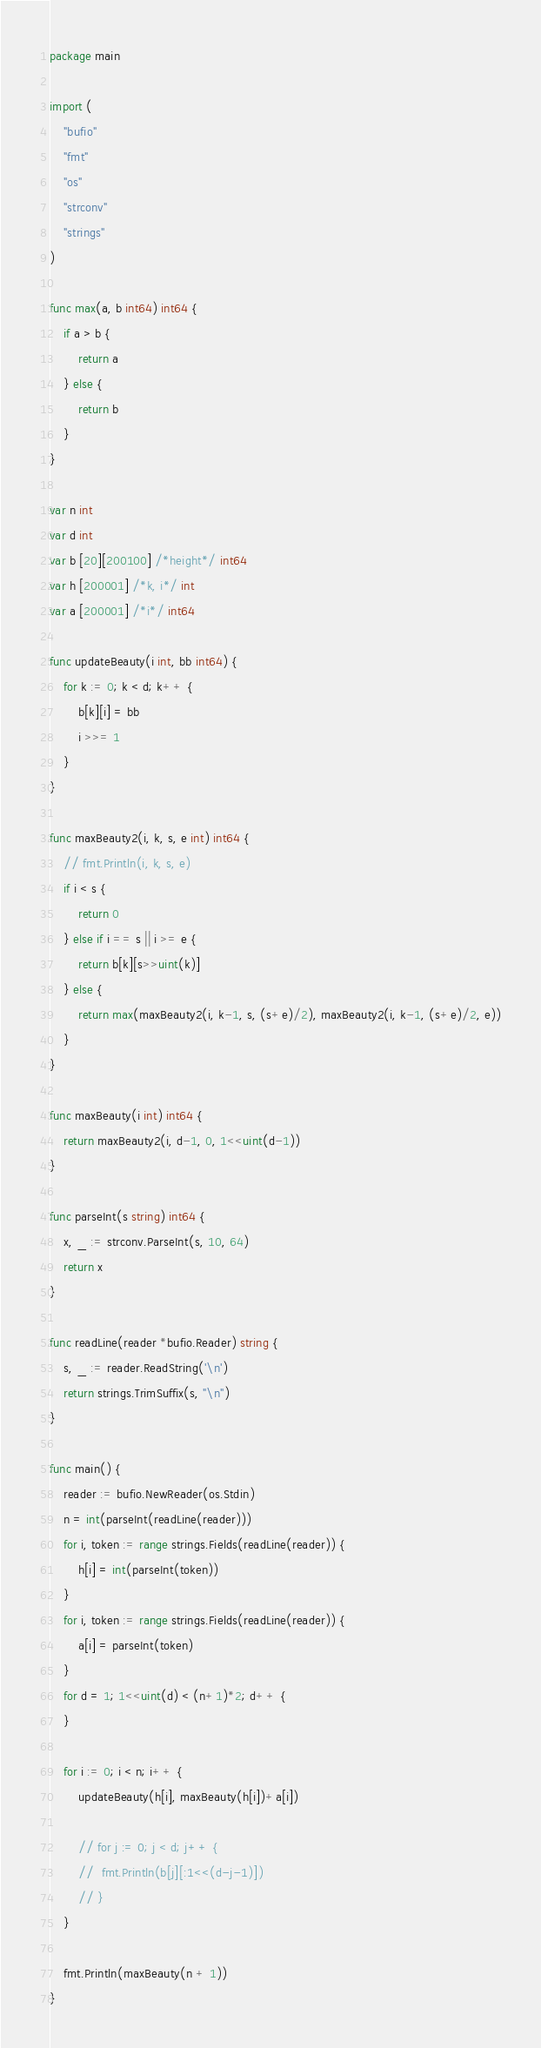<code> <loc_0><loc_0><loc_500><loc_500><_Go_>package main

import (
	"bufio"
	"fmt"
	"os"
	"strconv"
	"strings"
)

func max(a, b int64) int64 {
	if a > b {
		return a
	} else {
		return b
	}
}

var n int
var d int
var b [20][200100] /*height*/ int64
var h [200001] /*k, i*/ int
var a [200001] /*i*/ int64

func updateBeauty(i int, bb int64) {
	for k := 0; k < d; k++ {
		b[k][i] = bb
		i >>= 1
	}
}

func maxBeauty2(i, k, s, e int) int64 {
	// fmt.Println(i, k, s, e)
	if i < s {
		return 0
	} else if i == s || i >= e {
		return b[k][s>>uint(k)]
	} else {
		return max(maxBeauty2(i, k-1, s, (s+e)/2), maxBeauty2(i, k-1, (s+e)/2, e))
	}
}

func maxBeauty(i int) int64 {
	return maxBeauty2(i, d-1, 0, 1<<uint(d-1))
}

func parseInt(s string) int64 {
	x, _ := strconv.ParseInt(s, 10, 64)
	return x
}

func readLine(reader *bufio.Reader) string {
	s, _ := reader.ReadString('\n')
	return strings.TrimSuffix(s, "\n")
}

func main() {
	reader := bufio.NewReader(os.Stdin)
	n = int(parseInt(readLine(reader)))
	for i, token := range strings.Fields(readLine(reader)) {
		h[i] = int(parseInt(token))
	}
	for i, token := range strings.Fields(readLine(reader)) {
		a[i] = parseInt(token)
	}
	for d = 1; 1<<uint(d) < (n+1)*2; d++ {
	}

	for i := 0; i < n; i++ {
		updateBeauty(h[i], maxBeauty(h[i])+a[i])

		// for j := 0; j < d; j++ {
		// 	fmt.Println(b[j][:1<<(d-j-1)])
		// }
	}

	fmt.Println(maxBeauty(n + 1))
}
</code> 